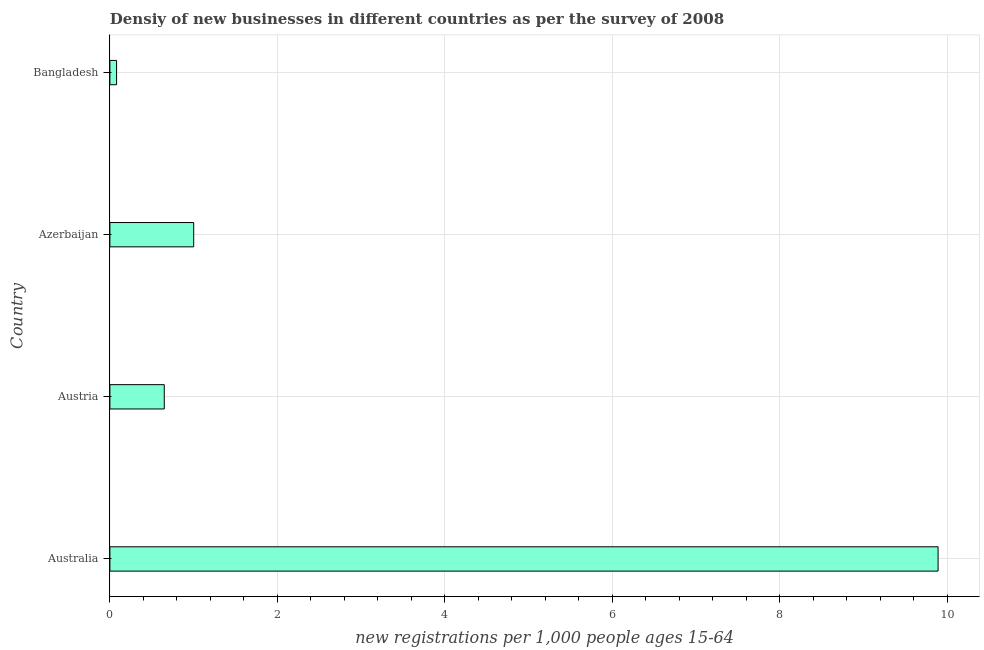Does the graph contain grids?
Your response must be concise. Yes. What is the title of the graph?
Your answer should be compact. Densiy of new businesses in different countries as per the survey of 2008. What is the label or title of the X-axis?
Ensure brevity in your answer.  New registrations per 1,0 people ages 15-64. What is the density of new business in Bangladesh?
Provide a succinct answer. 0.08. Across all countries, what is the maximum density of new business?
Keep it short and to the point. 9.89. Across all countries, what is the minimum density of new business?
Provide a short and direct response. 0.08. In which country was the density of new business minimum?
Your response must be concise. Bangladesh. What is the sum of the density of new business?
Offer a very short reply. 11.62. What is the difference between the density of new business in Australia and Azerbaijan?
Offer a terse response. 8.89. What is the average density of new business per country?
Make the answer very short. 2.9. What is the median density of new business?
Keep it short and to the point. 0.83. In how many countries, is the density of new business greater than 1.2 ?
Make the answer very short. 1. What is the ratio of the density of new business in Australia to that in Austria?
Give a very brief answer. 15.23. Is the density of new business in Azerbaijan less than that in Bangladesh?
Your answer should be very brief. No. What is the difference between the highest and the second highest density of new business?
Ensure brevity in your answer.  8.89. Is the sum of the density of new business in Austria and Bangladesh greater than the maximum density of new business across all countries?
Make the answer very short. No. What is the difference between the highest and the lowest density of new business?
Your answer should be very brief. 9.81. Are all the bars in the graph horizontal?
Your answer should be very brief. Yes. What is the new registrations per 1,000 people ages 15-64 in Australia?
Offer a terse response. 9.89. What is the new registrations per 1,000 people ages 15-64 of Austria?
Your answer should be very brief. 0.65. What is the new registrations per 1,000 people ages 15-64 in Azerbaijan?
Your response must be concise. 1. What is the new registrations per 1,000 people ages 15-64 of Bangladesh?
Your response must be concise. 0.08. What is the difference between the new registrations per 1,000 people ages 15-64 in Australia and Austria?
Provide a short and direct response. 9.24. What is the difference between the new registrations per 1,000 people ages 15-64 in Australia and Azerbaijan?
Give a very brief answer. 8.89. What is the difference between the new registrations per 1,000 people ages 15-64 in Australia and Bangladesh?
Offer a terse response. 9.81. What is the difference between the new registrations per 1,000 people ages 15-64 in Austria and Azerbaijan?
Offer a terse response. -0.35. What is the difference between the new registrations per 1,000 people ages 15-64 in Austria and Bangladesh?
Ensure brevity in your answer.  0.57. What is the difference between the new registrations per 1,000 people ages 15-64 in Azerbaijan and Bangladesh?
Provide a succinct answer. 0.92. What is the ratio of the new registrations per 1,000 people ages 15-64 in Australia to that in Austria?
Offer a very short reply. 15.23. What is the ratio of the new registrations per 1,000 people ages 15-64 in Australia to that in Azerbaijan?
Your answer should be very brief. 9.88. What is the ratio of the new registrations per 1,000 people ages 15-64 in Australia to that in Bangladesh?
Your response must be concise. 123.74. What is the ratio of the new registrations per 1,000 people ages 15-64 in Austria to that in Azerbaijan?
Your answer should be very brief. 0.65. What is the ratio of the new registrations per 1,000 people ages 15-64 in Austria to that in Bangladesh?
Make the answer very short. 8.12. What is the ratio of the new registrations per 1,000 people ages 15-64 in Azerbaijan to that in Bangladesh?
Keep it short and to the point. 12.52. 